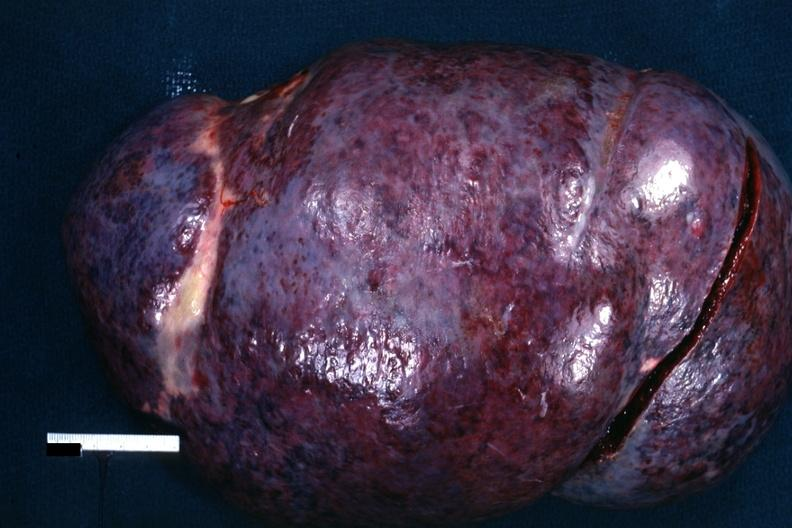what is present?
Answer the question using a single word or phrase. Hematologic 